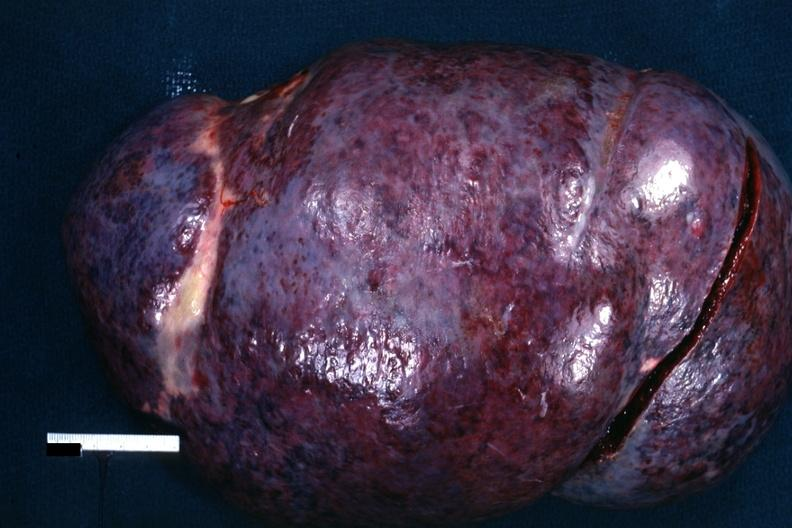what is present?
Answer the question using a single word or phrase. Hematologic 